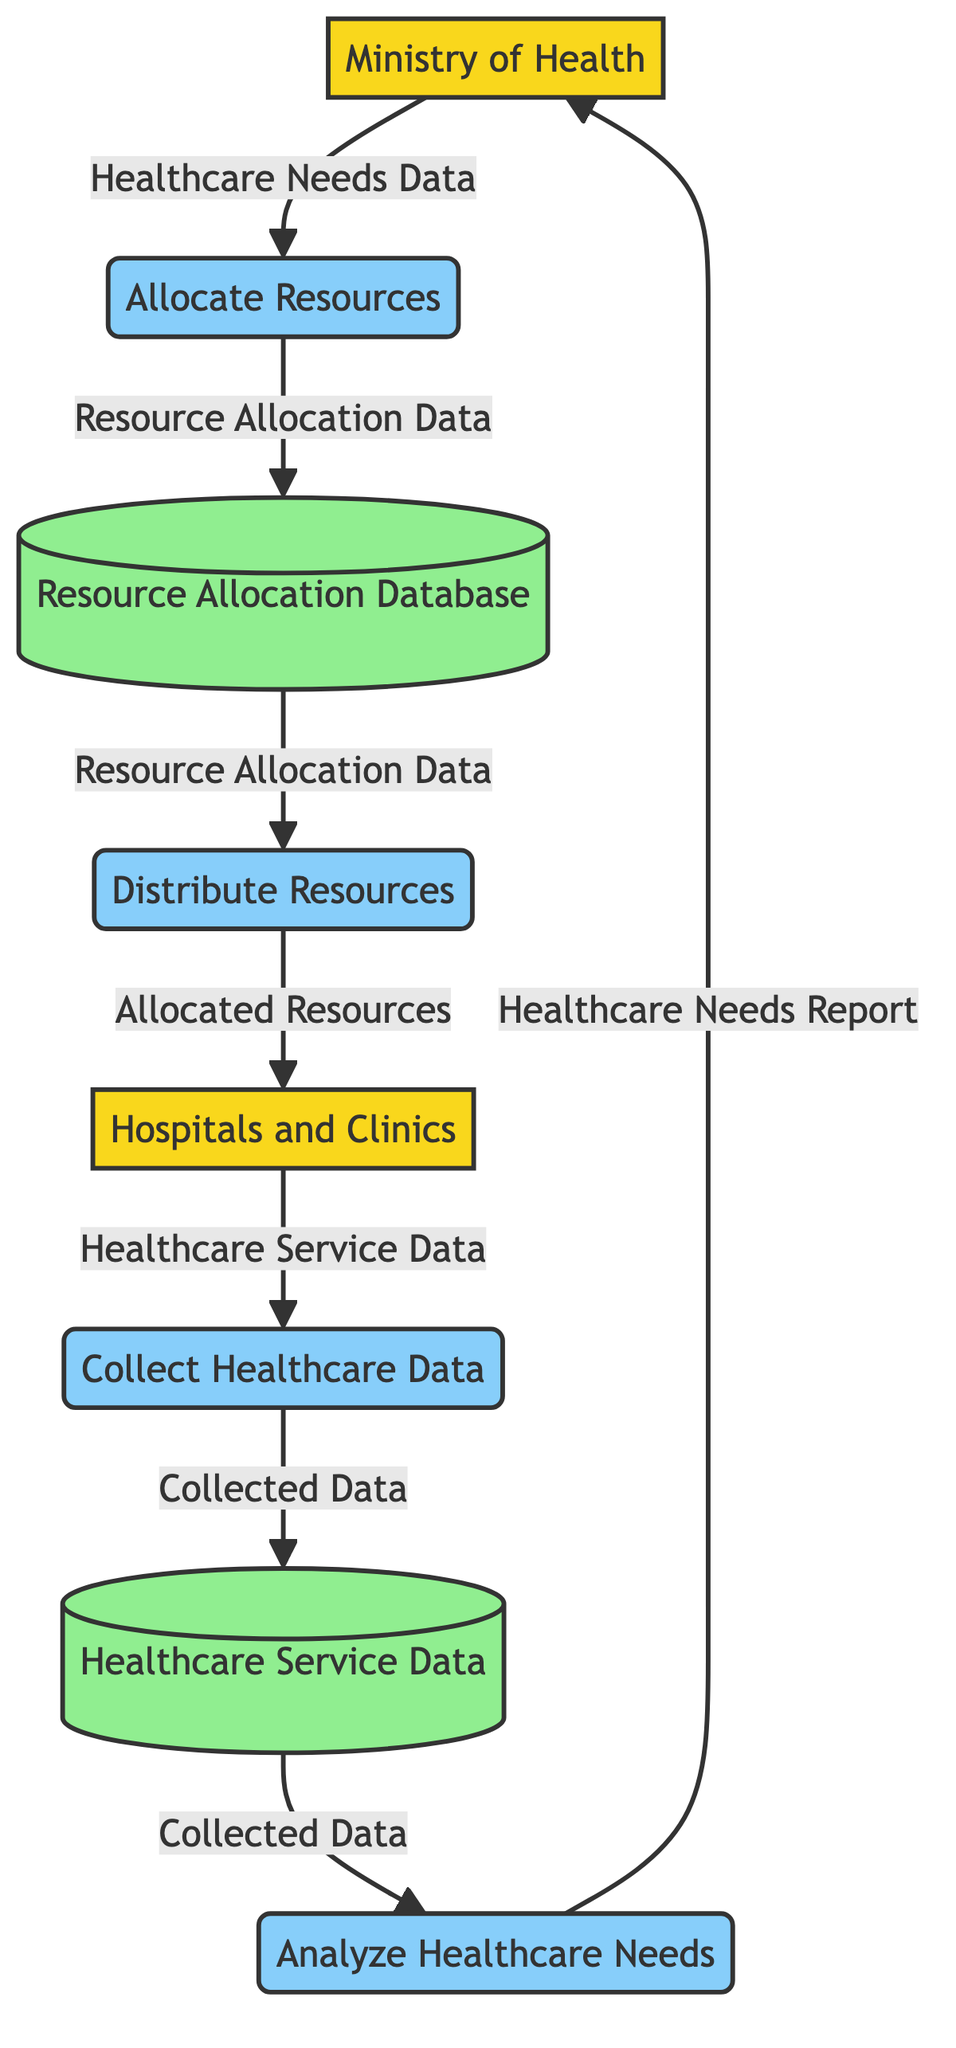What's the first process in the diagram? The first process is identified as "Collect Healthcare Data" which is the initial step where data is gathered from the Hospitals and Clinics.
Answer: Collect Healthcare Data How many external entities are represented in the diagram? The diagram includes two external entities, which are the Ministry of Health and Hospitals and Clinics.
Answer: 2 What is the output of the "Analyze Healthcare Needs" process? The output of the "Analyze Healthcare Needs" process is the "Healthcare Needs Report," which is sent to the Ministry of Health.
Answer: Healthcare Needs Report Which data store receives the output from the "Allocate Resources" process? The "Resource Allocation Database" receives the output named "Resource Allocation Data" from the "Allocate Resources" process.
Answer: Resource Allocation Database What is the primary flow from "Collect Healthcare Data" to "Analyze Healthcare Needs"? The primary flow is that "Collected Data" is output from "Collect Healthcare Data" and serves as input for "Analyze Healthcare Needs," indicating that the process analyses the gathered data.
Answer: Collected Data Which two processes are linked to the "Resource Allocation Database"? The two processes linked to the "Resource Allocation Database" are "Allocate Resources" and "Distribute Resources," which interact with it for allocation and distribution respectively.
Answer: Allocate Resources, Distribute Resources What type of data store is "Healthcare Service Data"? "Healthcare Service Data" is categorized as a data store in the diagram, specifically used to store collected healthcare service data.
Answer: Data Store What does the "Distribute Resources" process output? The "Distribute Resources" process outputs "Allocated Resources" which are given to the Hospitals and Clinics, completing the distribution of resources based on prior allocation.
Answer: Allocated Resources Which entity is the final recipient of the data flow in the diagram? The final recipient of the data flow is the "Hospitals and Clinics," which receive the allocated resources after the entire process of allocation and distribution.
Answer: Hospitals and Clinics 